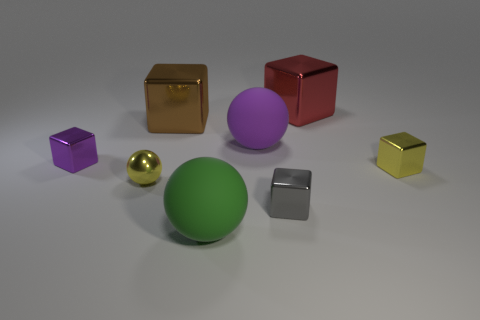Are there fewer brown things that are right of the small yellow block than green matte balls?
Provide a short and direct response. Yes. What is the color of the shiny ball?
Keep it short and to the point. Yellow. There is a large matte thing that is to the right of the large green matte ball; does it have the same color as the small metal ball?
Your response must be concise. No. There is another big object that is the same shape as the big red metal thing; what is its color?
Your answer should be compact. Brown. How many big objects are either purple matte spheres or yellow rubber blocks?
Your response must be concise. 1. What size is the matte ball on the left side of the large purple rubber object?
Provide a short and direct response. Large. Are there any big spheres of the same color as the small metallic sphere?
Provide a short and direct response. No. What is the shape of the small shiny thing that is the same color as the metallic sphere?
Provide a succinct answer. Cube. How many red objects are in front of the purple thing right of the small purple metallic thing?
Give a very brief answer. 0. What number of purple cubes have the same material as the purple sphere?
Give a very brief answer. 0. 